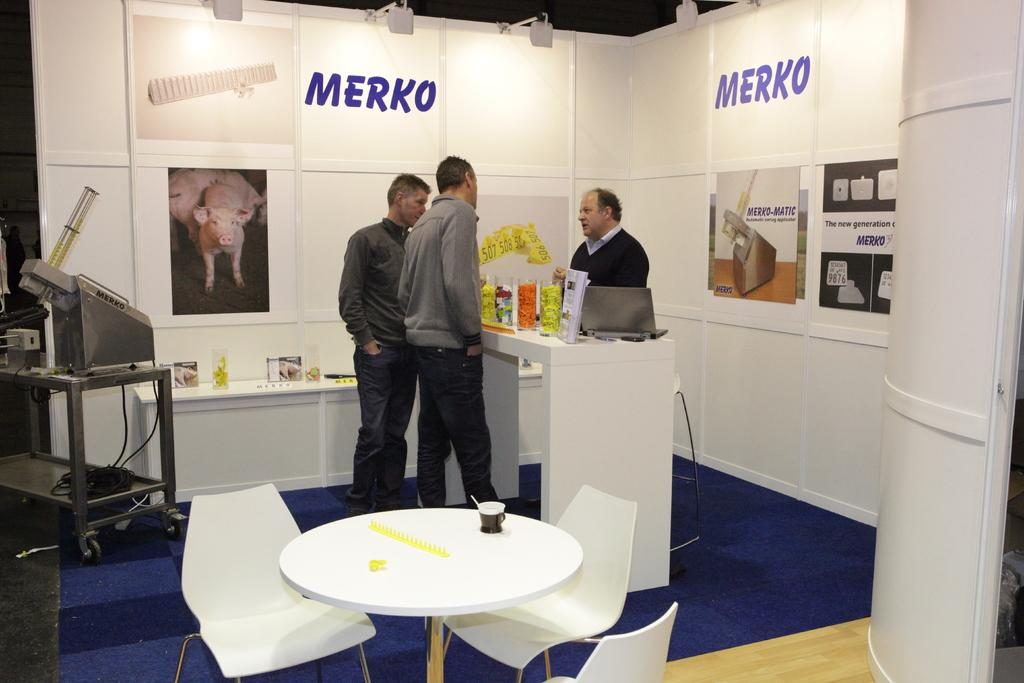How many people are present in the image? There are three people standing in the image. What is on the table in the image? There is a cup on a table in the image. What type of furniture is visible in the image? There are chairs in the image. What type of decorations are present in the image? There are posters in the image. What is the setting of the image? The setting appears to be a cabin. What type of railway is visible in the image? There is no railway present in the image. How does the balloon contribute to the decoration in the image? There is no balloon present in the image. 